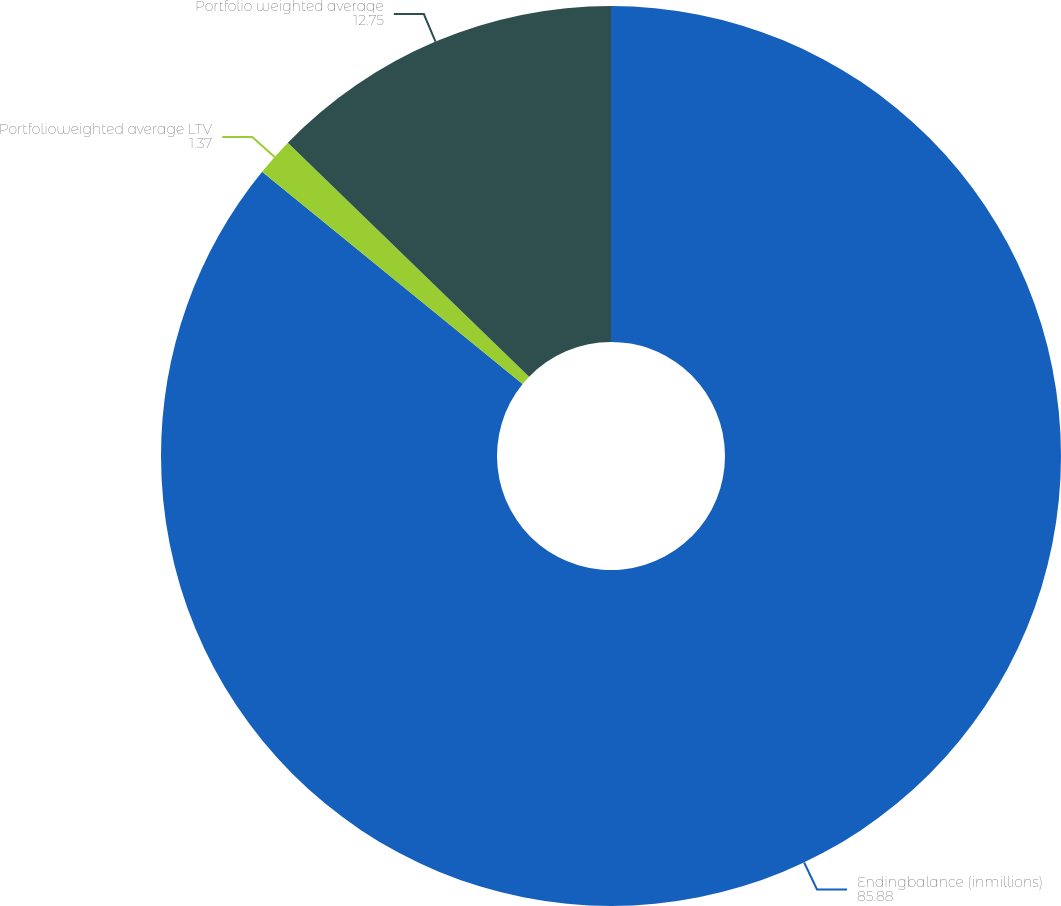<chart> <loc_0><loc_0><loc_500><loc_500><pie_chart><fcel>Endingbalance (inmillions)<fcel>Portfolioweighted average LTV<fcel>Portfolio weighted average<nl><fcel>85.88%<fcel>1.37%<fcel>12.75%<nl></chart> 